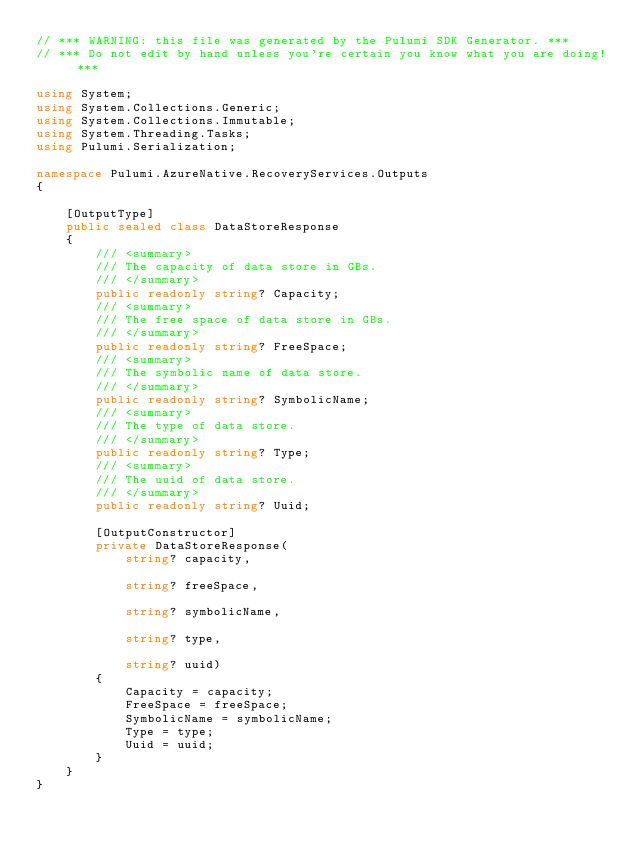Convert code to text. <code><loc_0><loc_0><loc_500><loc_500><_C#_>// *** WARNING: this file was generated by the Pulumi SDK Generator. ***
// *** Do not edit by hand unless you're certain you know what you are doing! ***

using System;
using System.Collections.Generic;
using System.Collections.Immutable;
using System.Threading.Tasks;
using Pulumi.Serialization;

namespace Pulumi.AzureNative.RecoveryServices.Outputs
{

    [OutputType]
    public sealed class DataStoreResponse
    {
        /// <summary>
        /// The capacity of data store in GBs.
        /// </summary>
        public readonly string? Capacity;
        /// <summary>
        /// The free space of data store in GBs.
        /// </summary>
        public readonly string? FreeSpace;
        /// <summary>
        /// The symbolic name of data store.
        /// </summary>
        public readonly string? SymbolicName;
        /// <summary>
        /// The type of data store.
        /// </summary>
        public readonly string? Type;
        /// <summary>
        /// The uuid of data store.
        /// </summary>
        public readonly string? Uuid;

        [OutputConstructor]
        private DataStoreResponse(
            string? capacity,

            string? freeSpace,

            string? symbolicName,

            string? type,

            string? uuid)
        {
            Capacity = capacity;
            FreeSpace = freeSpace;
            SymbolicName = symbolicName;
            Type = type;
            Uuid = uuid;
        }
    }
}
</code> 